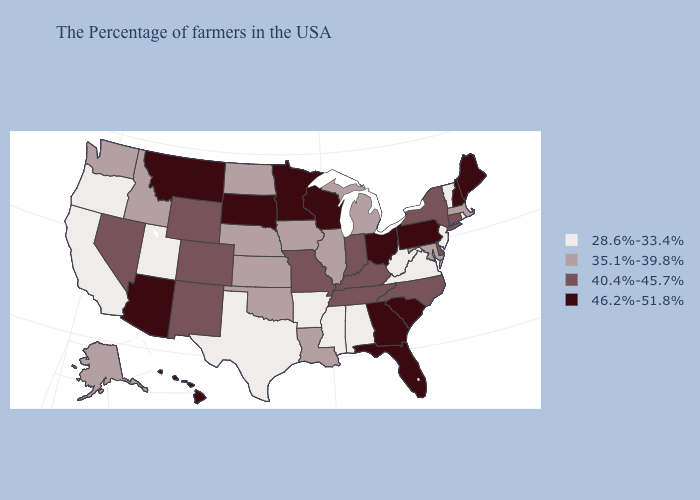Which states have the lowest value in the Northeast?
Be succinct. Rhode Island, Vermont, New Jersey. What is the highest value in the USA?
Be succinct. 46.2%-51.8%. Among the states that border Colorado , does Arizona have the highest value?
Quick response, please. Yes. Does Pennsylvania have the highest value in the Northeast?
Keep it brief. Yes. Among the states that border Nevada , which have the highest value?
Short answer required. Arizona. Name the states that have a value in the range 40.4%-45.7%?
Short answer required. Connecticut, New York, Delaware, North Carolina, Kentucky, Indiana, Tennessee, Missouri, Wyoming, Colorado, New Mexico, Nevada. What is the value of Idaho?
Give a very brief answer. 35.1%-39.8%. Which states have the lowest value in the USA?
Quick response, please. Rhode Island, Vermont, New Jersey, Virginia, West Virginia, Alabama, Mississippi, Arkansas, Texas, Utah, California, Oregon. What is the lowest value in the USA?
Keep it brief. 28.6%-33.4%. Does Maine have a higher value than Delaware?
Short answer required. Yes. What is the value of Louisiana?
Answer briefly. 35.1%-39.8%. Among the states that border Oregon , does Nevada have the highest value?
Write a very short answer. Yes. Does Minnesota have the highest value in the MidWest?
Concise answer only. Yes. Does Nevada have a higher value than Virginia?
Short answer required. Yes. What is the highest value in states that border Washington?
Keep it brief. 35.1%-39.8%. 